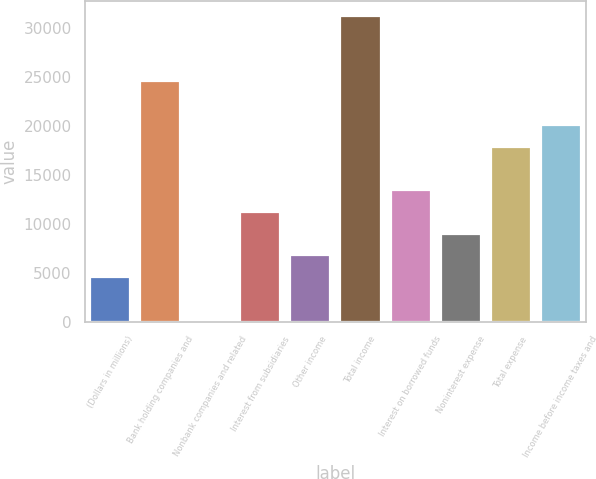Convert chart to OTSL. <chart><loc_0><loc_0><loc_500><loc_500><bar_chart><fcel>(Dollars in millions)<fcel>Bank holding companies and<fcel>Nonbank companies and related<fcel>Interest from subsidiaries<fcel>Other income<fcel>Total income<fcel>Interest on borrowed funds<fcel>Noninterest expense<fcel>Total expense<fcel>Income before income taxes and<nl><fcel>4559<fcel>24575<fcel>111<fcel>11231<fcel>6783<fcel>31247<fcel>13455<fcel>9007<fcel>17903<fcel>20127<nl></chart> 